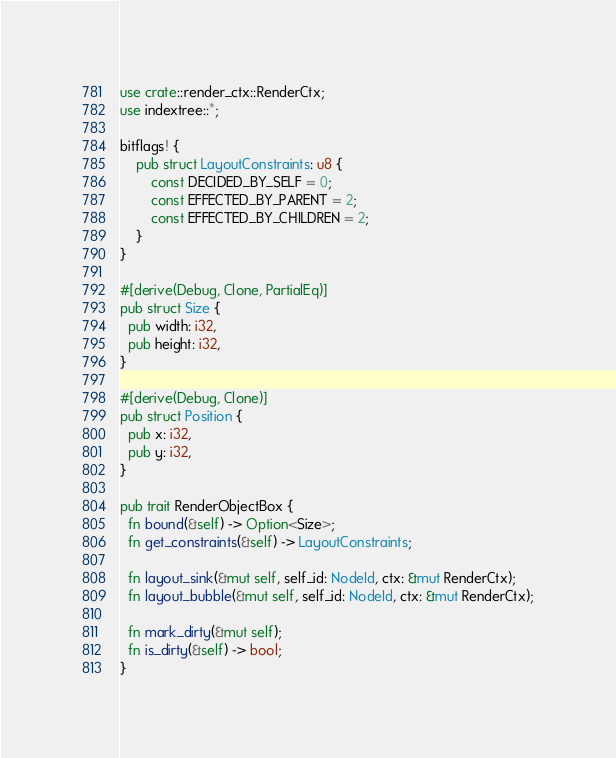Convert code to text. <code><loc_0><loc_0><loc_500><loc_500><_Rust_>use crate::render_ctx::RenderCtx;
use indextree::*;

bitflags! {
    pub struct LayoutConstraints: u8 {
        const DECIDED_BY_SELF = 0;
        const EFFECTED_BY_PARENT = 2;
        const EFFECTED_BY_CHILDREN = 2;
    }
}

#[derive(Debug, Clone, PartialEq)]
pub struct Size {
  pub width: i32,
  pub height: i32,
}

#[derive(Debug, Clone)]
pub struct Position {
  pub x: i32,
  pub y: i32,
}

pub trait RenderObjectBox {
  fn bound(&self) -> Option<Size>;
  fn get_constraints(&self) -> LayoutConstraints;

  fn layout_sink(&mut self, self_id: NodeId, ctx: &mut RenderCtx);
  fn layout_bubble(&mut self, self_id: NodeId, ctx: &mut RenderCtx);

  fn mark_dirty(&mut self);
  fn is_dirty(&self) -> bool;
}
</code> 